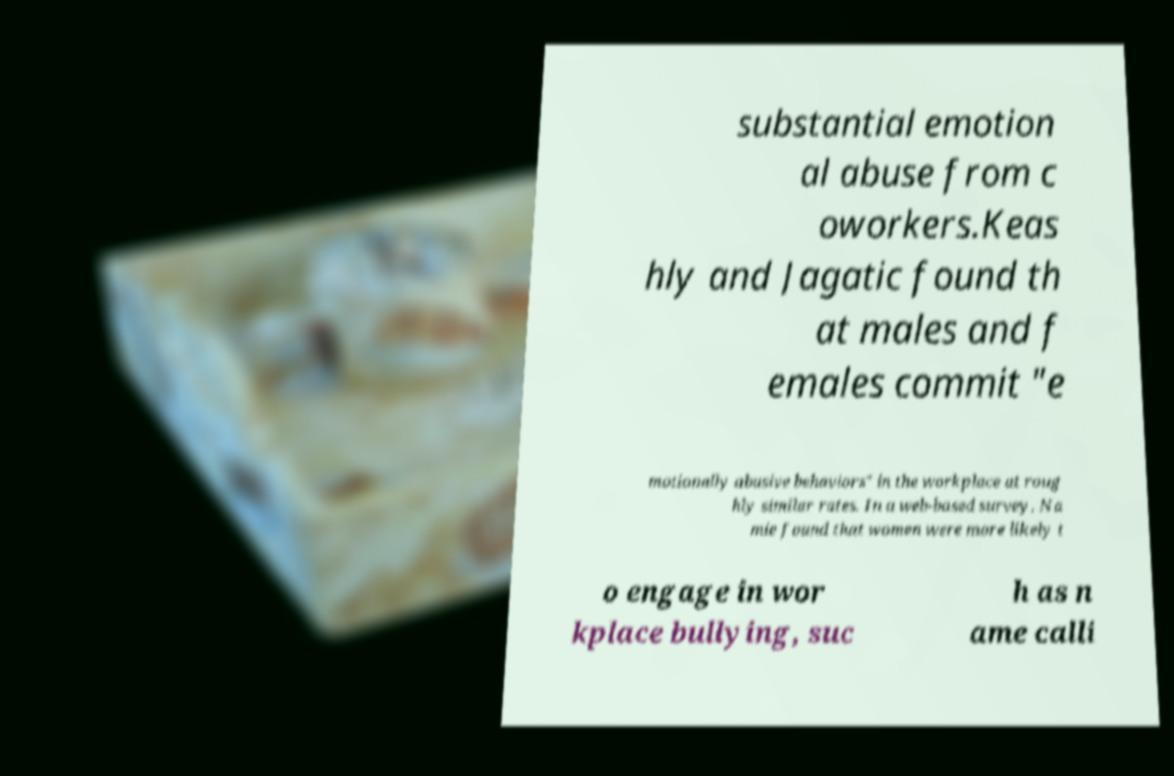For documentation purposes, I need the text within this image transcribed. Could you provide that? substantial emotion al abuse from c oworkers.Keas hly and Jagatic found th at males and f emales commit "e motionally abusive behaviors" in the workplace at roug hly similar rates. In a web-based survey, Na mie found that women were more likely t o engage in wor kplace bullying, suc h as n ame calli 